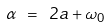Convert formula to latex. <formula><loc_0><loc_0><loc_500><loc_500>\alpha \ = \ 2 a + \omega _ { 0 }</formula> 